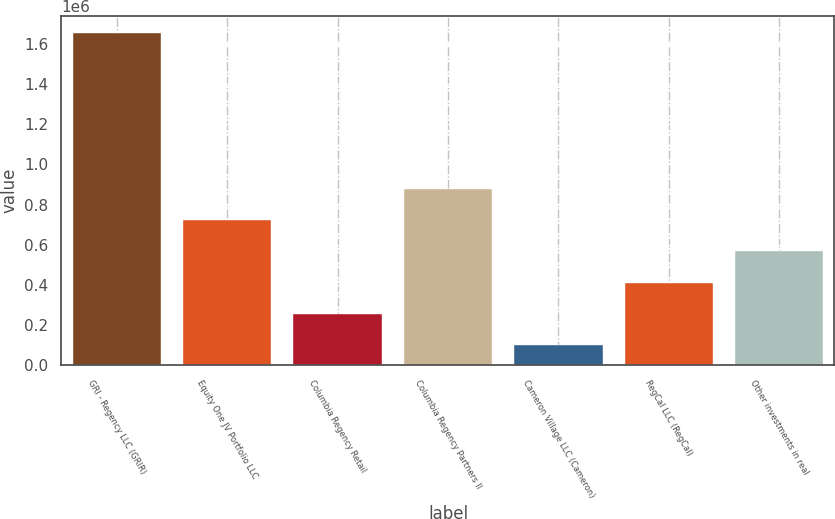Convert chart. <chart><loc_0><loc_0><loc_500><loc_500><bar_chart><fcel>GRI - Regency LLC (GRIR)<fcel>Equity One JV Portfolio LLC<fcel>Columbia Regency Retail<fcel>Columbia Regency Partners II<fcel>Cameron Village LLC (Cameron)<fcel>RegCal LLC (RegCal)<fcel>Other investments in real<nl><fcel>1.65607e+06<fcel>722312<fcel>255434<fcel>877938<fcel>99808<fcel>411060<fcel>566686<nl></chart> 